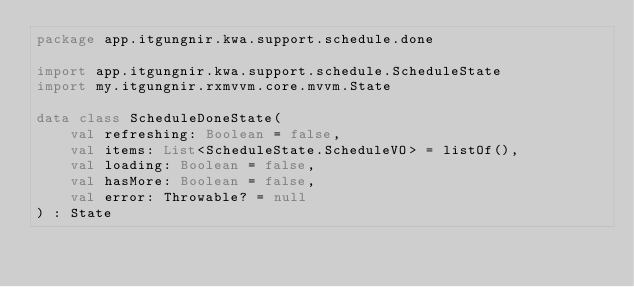Convert code to text. <code><loc_0><loc_0><loc_500><loc_500><_Kotlin_>package app.itgungnir.kwa.support.schedule.done

import app.itgungnir.kwa.support.schedule.ScheduleState
import my.itgungnir.rxmvvm.core.mvvm.State

data class ScheduleDoneState(
    val refreshing: Boolean = false,
    val items: List<ScheduleState.ScheduleVO> = listOf(),
    val loading: Boolean = false,
    val hasMore: Boolean = false,
    val error: Throwable? = null
) : State</code> 